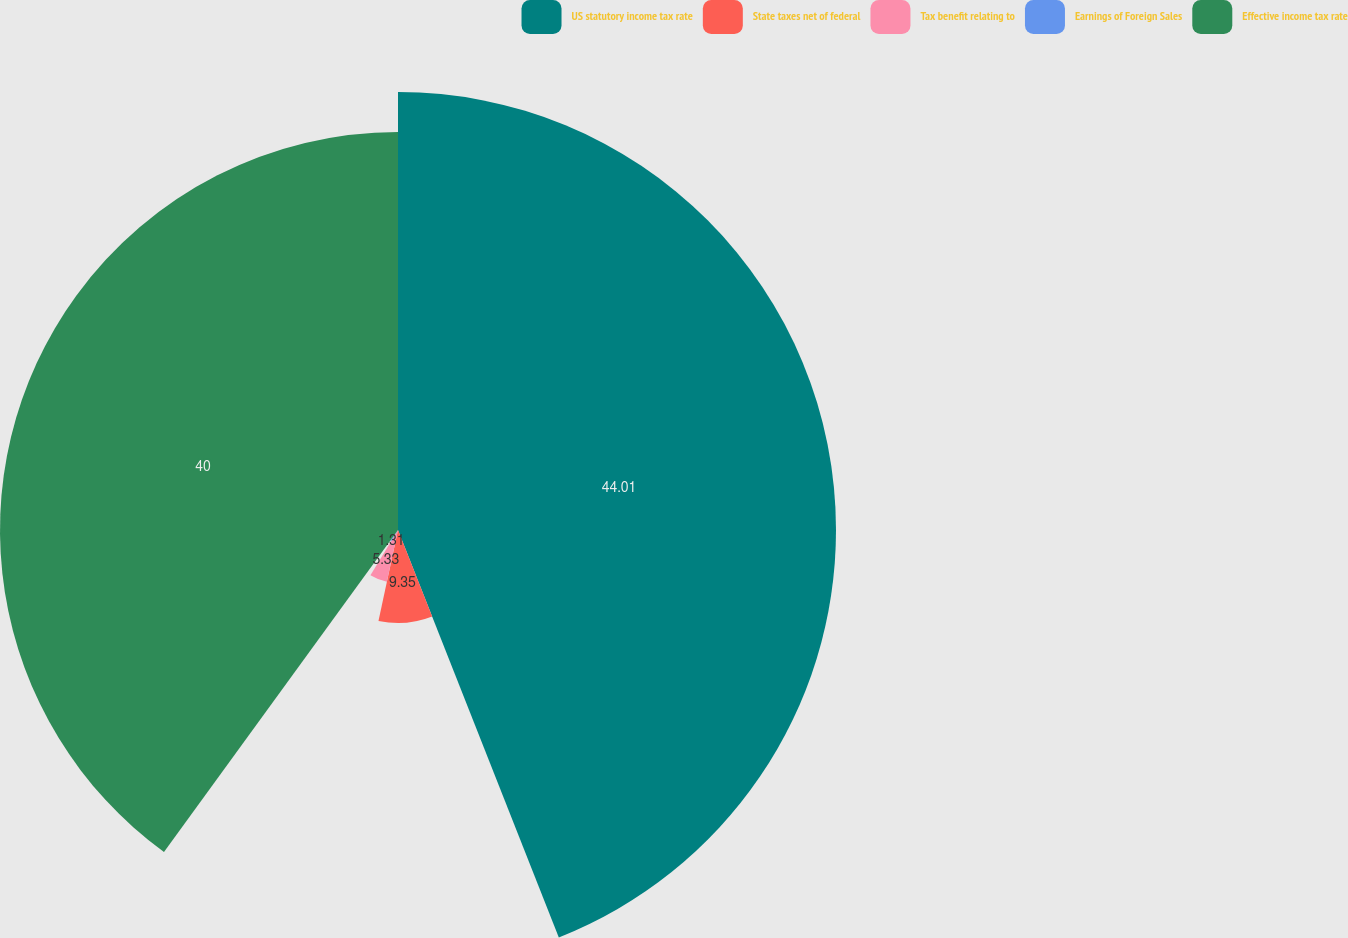Convert chart to OTSL. <chart><loc_0><loc_0><loc_500><loc_500><pie_chart><fcel>US statutory income tax rate<fcel>State taxes net of federal<fcel>Tax benefit relating to<fcel>Earnings of Foreign Sales<fcel>Effective income tax rate<nl><fcel>44.02%<fcel>9.35%<fcel>5.33%<fcel>1.31%<fcel>40.0%<nl></chart> 